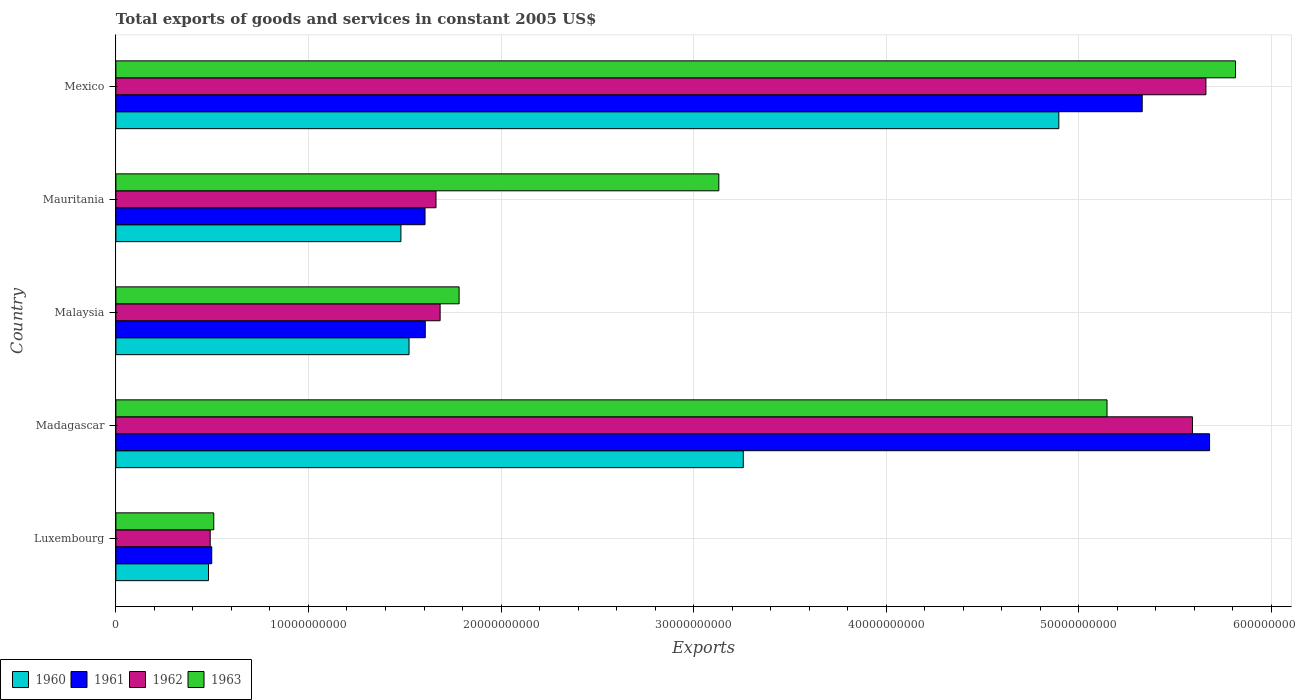What is the label of the 5th group of bars from the top?
Keep it short and to the point. Luxembourg. In how many cases, is the number of bars for a given country not equal to the number of legend labels?
Offer a terse response. 0. What is the total exports of goods and services in 1963 in Malaysia?
Keep it short and to the point. 1.78e+1. Across all countries, what is the maximum total exports of goods and services in 1962?
Your response must be concise. 5.66e+1. Across all countries, what is the minimum total exports of goods and services in 1962?
Offer a terse response. 4.90e+09. In which country was the total exports of goods and services in 1960 minimum?
Keep it short and to the point. Luxembourg. What is the total total exports of goods and services in 1961 in the graph?
Provide a short and direct response. 1.47e+11. What is the difference between the total exports of goods and services in 1962 in Luxembourg and that in Malaysia?
Offer a terse response. -1.19e+1. What is the difference between the total exports of goods and services in 1960 in Luxembourg and the total exports of goods and services in 1961 in Mexico?
Ensure brevity in your answer.  -4.85e+1. What is the average total exports of goods and services in 1962 per country?
Your answer should be very brief. 3.02e+1. What is the difference between the total exports of goods and services in 1963 and total exports of goods and services in 1960 in Malaysia?
Your answer should be compact. 2.60e+09. What is the ratio of the total exports of goods and services in 1963 in Madagascar to that in Mexico?
Ensure brevity in your answer.  0.89. Is the total exports of goods and services in 1962 in Madagascar less than that in Malaysia?
Offer a terse response. No. Is the difference between the total exports of goods and services in 1963 in Luxembourg and Mauritania greater than the difference between the total exports of goods and services in 1960 in Luxembourg and Mauritania?
Offer a very short reply. No. What is the difference between the highest and the second highest total exports of goods and services in 1962?
Your answer should be compact. 6.99e+08. What is the difference between the highest and the lowest total exports of goods and services in 1961?
Give a very brief answer. 5.18e+1. In how many countries, is the total exports of goods and services in 1960 greater than the average total exports of goods and services in 1960 taken over all countries?
Your answer should be compact. 2. Is it the case that in every country, the sum of the total exports of goods and services in 1961 and total exports of goods and services in 1962 is greater than the sum of total exports of goods and services in 1963 and total exports of goods and services in 1960?
Ensure brevity in your answer.  No. What does the 2nd bar from the bottom in Luxembourg represents?
Give a very brief answer. 1961. What is the difference between two consecutive major ticks on the X-axis?
Offer a very short reply. 1.00e+1. Does the graph contain any zero values?
Your answer should be very brief. No. Does the graph contain grids?
Make the answer very short. Yes. Where does the legend appear in the graph?
Your response must be concise. Bottom left. What is the title of the graph?
Offer a terse response. Total exports of goods and services in constant 2005 US$. Does "1999" appear as one of the legend labels in the graph?
Your answer should be compact. No. What is the label or title of the X-axis?
Make the answer very short. Exports. What is the label or title of the Y-axis?
Your answer should be compact. Country. What is the Exports in 1960 in Luxembourg?
Keep it short and to the point. 4.81e+09. What is the Exports of 1961 in Luxembourg?
Your answer should be very brief. 4.98e+09. What is the Exports of 1962 in Luxembourg?
Provide a succinct answer. 4.90e+09. What is the Exports in 1963 in Luxembourg?
Make the answer very short. 5.08e+09. What is the Exports of 1960 in Madagascar?
Provide a short and direct response. 3.26e+1. What is the Exports of 1961 in Madagascar?
Your answer should be very brief. 5.68e+1. What is the Exports of 1962 in Madagascar?
Provide a succinct answer. 5.59e+1. What is the Exports in 1963 in Madagascar?
Offer a very short reply. 5.15e+1. What is the Exports in 1960 in Malaysia?
Provide a short and direct response. 1.52e+1. What is the Exports in 1961 in Malaysia?
Keep it short and to the point. 1.61e+1. What is the Exports in 1962 in Malaysia?
Your response must be concise. 1.68e+1. What is the Exports in 1963 in Malaysia?
Offer a very short reply. 1.78e+1. What is the Exports in 1960 in Mauritania?
Keep it short and to the point. 1.48e+1. What is the Exports of 1961 in Mauritania?
Offer a very short reply. 1.61e+1. What is the Exports of 1962 in Mauritania?
Your response must be concise. 1.66e+1. What is the Exports in 1963 in Mauritania?
Make the answer very short. 3.13e+1. What is the Exports of 1960 in Mexico?
Your response must be concise. 4.90e+1. What is the Exports in 1961 in Mexico?
Provide a short and direct response. 5.33e+1. What is the Exports of 1962 in Mexico?
Offer a very short reply. 5.66e+1. What is the Exports in 1963 in Mexico?
Provide a succinct answer. 5.81e+1. Across all countries, what is the maximum Exports in 1960?
Make the answer very short. 4.90e+1. Across all countries, what is the maximum Exports in 1961?
Provide a short and direct response. 5.68e+1. Across all countries, what is the maximum Exports of 1962?
Keep it short and to the point. 5.66e+1. Across all countries, what is the maximum Exports in 1963?
Your response must be concise. 5.81e+1. Across all countries, what is the minimum Exports in 1960?
Your response must be concise. 4.81e+09. Across all countries, what is the minimum Exports of 1961?
Provide a short and direct response. 4.98e+09. Across all countries, what is the minimum Exports of 1962?
Provide a succinct answer. 4.90e+09. Across all countries, what is the minimum Exports of 1963?
Ensure brevity in your answer.  5.08e+09. What is the total Exports of 1960 in the graph?
Offer a very short reply. 1.16e+11. What is the total Exports in 1961 in the graph?
Make the answer very short. 1.47e+11. What is the total Exports in 1962 in the graph?
Your answer should be compact. 1.51e+11. What is the total Exports of 1963 in the graph?
Keep it short and to the point. 1.64e+11. What is the difference between the Exports of 1960 in Luxembourg and that in Madagascar?
Your answer should be compact. -2.78e+1. What is the difference between the Exports in 1961 in Luxembourg and that in Madagascar?
Provide a short and direct response. -5.18e+1. What is the difference between the Exports in 1962 in Luxembourg and that in Madagascar?
Ensure brevity in your answer.  -5.10e+1. What is the difference between the Exports of 1963 in Luxembourg and that in Madagascar?
Your answer should be very brief. -4.64e+1. What is the difference between the Exports of 1960 in Luxembourg and that in Malaysia?
Make the answer very short. -1.04e+1. What is the difference between the Exports of 1961 in Luxembourg and that in Malaysia?
Make the answer very short. -1.11e+1. What is the difference between the Exports in 1962 in Luxembourg and that in Malaysia?
Your answer should be very brief. -1.19e+1. What is the difference between the Exports in 1963 in Luxembourg and that in Malaysia?
Your answer should be very brief. -1.27e+1. What is the difference between the Exports in 1960 in Luxembourg and that in Mauritania?
Offer a very short reply. -9.99e+09. What is the difference between the Exports of 1961 in Luxembourg and that in Mauritania?
Provide a short and direct response. -1.11e+1. What is the difference between the Exports of 1962 in Luxembourg and that in Mauritania?
Offer a very short reply. -1.17e+1. What is the difference between the Exports of 1963 in Luxembourg and that in Mauritania?
Offer a very short reply. -2.62e+1. What is the difference between the Exports of 1960 in Luxembourg and that in Mexico?
Provide a succinct answer. -4.42e+1. What is the difference between the Exports in 1961 in Luxembourg and that in Mexico?
Offer a terse response. -4.83e+1. What is the difference between the Exports in 1962 in Luxembourg and that in Mexico?
Provide a succinct answer. -5.17e+1. What is the difference between the Exports of 1963 in Luxembourg and that in Mexico?
Ensure brevity in your answer.  -5.31e+1. What is the difference between the Exports in 1960 in Madagascar and that in Malaysia?
Provide a short and direct response. 1.74e+1. What is the difference between the Exports in 1961 in Madagascar and that in Malaysia?
Your response must be concise. 4.07e+1. What is the difference between the Exports in 1962 in Madagascar and that in Malaysia?
Ensure brevity in your answer.  3.91e+1. What is the difference between the Exports of 1963 in Madagascar and that in Malaysia?
Your response must be concise. 3.36e+1. What is the difference between the Exports in 1960 in Madagascar and that in Mauritania?
Offer a terse response. 1.78e+1. What is the difference between the Exports in 1961 in Madagascar and that in Mauritania?
Provide a succinct answer. 4.07e+1. What is the difference between the Exports of 1962 in Madagascar and that in Mauritania?
Ensure brevity in your answer.  3.93e+1. What is the difference between the Exports in 1963 in Madagascar and that in Mauritania?
Provide a short and direct response. 2.02e+1. What is the difference between the Exports of 1960 in Madagascar and that in Mexico?
Offer a terse response. -1.64e+1. What is the difference between the Exports in 1961 in Madagascar and that in Mexico?
Your answer should be very brief. 3.50e+09. What is the difference between the Exports in 1962 in Madagascar and that in Mexico?
Give a very brief answer. -6.99e+08. What is the difference between the Exports in 1963 in Madagascar and that in Mexico?
Your response must be concise. -6.67e+09. What is the difference between the Exports of 1960 in Malaysia and that in Mauritania?
Your answer should be very brief. 4.22e+08. What is the difference between the Exports of 1961 in Malaysia and that in Mauritania?
Make the answer very short. 1.20e+07. What is the difference between the Exports of 1962 in Malaysia and that in Mauritania?
Make the answer very short. 2.15e+08. What is the difference between the Exports in 1963 in Malaysia and that in Mauritania?
Offer a terse response. -1.35e+1. What is the difference between the Exports of 1960 in Malaysia and that in Mexico?
Offer a terse response. -3.37e+1. What is the difference between the Exports of 1961 in Malaysia and that in Mexico?
Keep it short and to the point. -3.72e+1. What is the difference between the Exports of 1962 in Malaysia and that in Mexico?
Provide a succinct answer. -3.98e+1. What is the difference between the Exports of 1963 in Malaysia and that in Mexico?
Make the answer very short. -4.03e+1. What is the difference between the Exports of 1960 in Mauritania and that in Mexico?
Ensure brevity in your answer.  -3.42e+1. What is the difference between the Exports of 1961 in Mauritania and that in Mexico?
Offer a terse response. -3.72e+1. What is the difference between the Exports of 1962 in Mauritania and that in Mexico?
Provide a short and direct response. -4.00e+1. What is the difference between the Exports in 1963 in Mauritania and that in Mexico?
Your response must be concise. -2.68e+1. What is the difference between the Exports of 1960 in Luxembourg and the Exports of 1961 in Madagascar?
Give a very brief answer. -5.20e+1. What is the difference between the Exports of 1960 in Luxembourg and the Exports of 1962 in Madagascar?
Offer a very short reply. -5.11e+1. What is the difference between the Exports in 1960 in Luxembourg and the Exports in 1963 in Madagascar?
Your answer should be compact. -4.67e+1. What is the difference between the Exports of 1961 in Luxembourg and the Exports of 1962 in Madagascar?
Provide a short and direct response. -5.09e+1. What is the difference between the Exports in 1961 in Luxembourg and the Exports in 1963 in Madagascar?
Offer a very short reply. -4.65e+1. What is the difference between the Exports of 1962 in Luxembourg and the Exports of 1963 in Madagascar?
Make the answer very short. -4.66e+1. What is the difference between the Exports in 1960 in Luxembourg and the Exports in 1961 in Malaysia?
Provide a succinct answer. -1.13e+1. What is the difference between the Exports of 1960 in Luxembourg and the Exports of 1962 in Malaysia?
Ensure brevity in your answer.  -1.20e+1. What is the difference between the Exports in 1960 in Luxembourg and the Exports in 1963 in Malaysia?
Your response must be concise. -1.30e+1. What is the difference between the Exports in 1961 in Luxembourg and the Exports in 1962 in Malaysia?
Your answer should be compact. -1.19e+1. What is the difference between the Exports of 1961 in Luxembourg and the Exports of 1963 in Malaysia?
Provide a succinct answer. -1.28e+1. What is the difference between the Exports in 1962 in Luxembourg and the Exports in 1963 in Malaysia?
Offer a very short reply. -1.29e+1. What is the difference between the Exports in 1960 in Luxembourg and the Exports in 1961 in Mauritania?
Offer a very short reply. -1.12e+1. What is the difference between the Exports in 1960 in Luxembourg and the Exports in 1962 in Mauritania?
Keep it short and to the point. -1.18e+1. What is the difference between the Exports in 1960 in Luxembourg and the Exports in 1963 in Mauritania?
Offer a terse response. -2.65e+1. What is the difference between the Exports in 1961 in Luxembourg and the Exports in 1962 in Mauritania?
Provide a short and direct response. -1.16e+1. What is the difference between the Exports of 1961 in Luxembourg and the Exports of 1963 in Mauritania?
Make the answer very short. -2.63e+1. What is the difference between the Exports of 1962 in Luxembourg and the Exports of 1963 in Mauritania?
Keep it short and to the point. -2.64e+1. What is the difference between the Exports of 1960 in Luxembourg and the Exports of 1961 in Mexico?
Provide a short and direct response. -4.85e+1. What is the difference between the Exports in 1960 in Luxembourg and the Exports in 1962 in Mexico?
Provide a succinct answer. -5.18e+1. What is the difference between the Exports in 1960 in Luxembourg and the Exports in 1963 in Mexico?
Provide a short and direct response. -5.33e+1. What is the difference between the Exports in 1961 in Luxembourg and the Exports in 1962 in Mexico?
Provide a short and direct response. -5.16e+1. What is the difference between the Exports in 1961 in Luxembourg and the Exports in 1963 in Mexico?
Ensure brevity in your answer.  -5.32e+1. What is the difference between the Exports of 1962 in Luxembourg and the Exports of 1963 in Mexico?
Provide a succinct answer. -5.32e+1. What is the difference between the Exports of 1960 in Madagascar and the Exports of 1961 in Malaysia?
Offer a terse response. 1.65e+1. What is the difference between the Exports of 1960 in Madagascar and the Exports of 1962 in Malaysia?
Your answer should be very brief. 1.57e+1. What is the difference between the Exports in 1960 in Madagascar and the Exports in 1963 in Malaysia?
Your answer should be very brief. 1.48e+1. What is the difference between the Exports in 1961 in Madagascar and the Exports in 1962 in Malaysia?
Offer a terse response. 4.00e+1. What is the difference between the Exports of 1961 in Madagascar and the Exports of 1963 in Malaysia?
Keep it short and to the point. 3.90e+1. What is the difference between the Exports in 1962 in Madagascar and the Exports in 1963 in Malaysia?
Ensure brevity in your answer.  3.81e+1. What is the difference between the Exports of 1960 in Madagascar and the Exports of 1961 in Mauritania?
Offer a terse response. 1.65e+1. What is the difference between the Exports in 1960 in Madagascar and the Exports in 1962 in Mauritania?
Your answer should be very brief. 1.60e+1. What is the difference between the Exports in 1960 in Madagascar and the Exports in 1963 in Mauritania?
Provide a short and direct response. 1.27e+09. What is the difference between the Exports in 1961 in Madagascar and the Exports in 1962 in Mauritania?
Your answer should be very brief. 4.02e+1. What is the difference between the Exports of 1961 in Madagascar and the Exports of 1963 in Mauritania?
Keep it short and to the point. 2.55e+1. What is the difference between the Exports of 1962 in Madagascar and the Exports of 1963 in Mauritania?
Ensure brevity in your answer.  2.46e+1. What is the difference between the Exports of 1960 in Madagascar and the Exports of 1961 in Mexico?
Offer a very short reply. -2.07e+1. What is the difference between the Exports in 1960 in Madagascar and the Exports in 1962 in Mexico?
Ensure brevity in your answer.  -2.40e+1. What is the difference between the Exports in 1960 in Madagascar and the Exports in 1963 in Mexico?
Give a very brief answer. -2.56e+1. What is the difference between the Exports in 1961 in Madagascar and the Exports in 1962 in Mexico?
Your response must be concise. 1.89e+08. What is the difference between the Exports in 1961 in Madagascar and the Exports in 1963 in Mexico?
Provide a short and direct response. -1.35e+09. What is the difference between the Exports in 1962 in Madagascar and the Exports in 1963 in Mexico?
Offer a very short reply. -2.24e+09. What is the difference between the Exports of 1960 in Malaysia and the Exports of 1961 in Mauritania?
Your response must be concise. -8.31e+08. What is the difference between the Exports of 1960 in Malaysia and the Exports of 1962 in Mauritania?
Make the answer very short. -1.40e+09. What is the difference between the Exports in 1960 in Malaysia and the Exports in 1963 in Mauritania?
Your answer should be very brief. -1.61e+1. What is the difference between the Exports of 1961 in Malaysia and the Exports of 1962 in Mauritania?
Provide a succinct answer. -5.57e+08. What is the difference between the Exports in 1961 in Malaysia and the Exports in 1963 in Mauritania?
Offer a very short reply. -1.52e+1. What is the difference between the Exports of 1962 in Malaysia and the Exports of 1963 in Mauritania?
Provide a succinct answer. -1.45e+1. What is the difference between the Exports of 1960 in Malaysia and the Exports of 1961 in Mexico?
Give a very brief answer. -3.81e+1. What is the difference between the Exports in 1960 in Malaysia and the Exports in 1962 in Mexico?
Make the answer very short. -4.14e+1. What is the difference between the Exports in 1960 in Malaysia and the Exports in 1963 in Mexico?
Provide a succinct answer. -4.29e+1. What is the difference between the Exports of 1961 in Malaysia and the Exports of 1962 in Mexico?
Offer a terse response. -4.05e+1. What is the difference between the Exports of 1961 in Malaysia and the Exports of 1963 in Mexico?
Make the answer very short. -4.21e+1. What is the difference between the Exports in 1962 in Malaysia and the Exports in 1963 in Mexico?
Offer a very short reply. -4.13e+1. What is the difference between the Exports in 1960 in Mauritania and the Exports in 1961 in Mexico?
Give a very brief answer. -3.85e+1. What is the difference between the Exports of 1960 in Mauritania and the Exports of 1962 in Mexico?
Ensure brevity in your answer.  -4.18e+1. What is the difference between the Exports in 1960 in Mauritania and the Exports in 1963 in Mexico?
Offer a terse response. -4.33e+1. What is the difference between the Exports in 1961 in Mauritania and the Exports in 1962 in Mexico?
Your response must be concise. -4.05e+1. What is the difference between the Exports in 1961 in Mauritania and the Exports in 1963 in Mexico?
Your answer should be compact. -4.21e+1. What is the difference between the Exports of 1962 in Mauritania and the Exports of 1963 in Mexico?
Make the answer very short. -4.15e+1. What is the average Exports of 1960 per country?
Give a very brief answer. 2.33e+1. What is the average Exports in 1961 per country?
Make the answer very short. 2.94e+1. What is the average Exports of 1962 per country?
Keep it short and to the point. 3.02e+1. What is the average Exports in 1963 per country?
Your answer should be very brief. 3.28e+1. What is the difference between the Exports in 1960 and Exports in 1961 in Luxembourg?
Provide a succinct answer. -1.68e+08. What is the difference between the Exports of 1960 and Exports of 1962 in Luxembourg?
Keep it short and to the point. -8.82e+07. What is the difference between the Exports of 1960 and Exports of 1963 in Luxembourg?
Provide a short and direct response. -2.73e+08. What is the difference between the Exports of 1961 and Exports of 1962 in Luxembourg?
Your answer should be compact. 7.94e+07. What is the difference between the Exports of 1961 and Exports of 1963 in Luxembourg?
Your response must be concise. -1.05e+08. What is the difference between the Exports in 1962 and Exports in 1963 in Luxembourg?
Your answer should be very brief. -1.85e+08. What is the difference between the Exports of 1960 and Exports of 1961 in Madagascar?
Make the answer very short. -2.42e+1. What is the difference between the Exports of 1960 and Exports of 1962 in Madagascar?
Offer a very short reply. -2.33e+1. What is the difference between the Exports in 1960 and Exports in 1963 in Madagascar?
Your answer should be very brief. -1.89e+1. What is the difference between the Exports in 1961 and Exports in 1962 in Madagascar?
Your answer should be compact. 8.87e+08. What is the difference between the Exports in 1961 and Exports in 1963 in Madagascar?
Your response must be concise. 5.32e+09. What is the difference between the Exports of 1962 and Exports of 1963 in Madagascar?
Your response must be concise. 4.44e+09. What is the difference between the Exports in 1960 and Exports in 1961 in Malaysia?
Provide a succinct answer. -8.42e+08. What is the difference between the Exports of 1960 and Exports of 1962 in Malaysia?
Keep it short and to the point. -1.61e+09. What is the difference between the Exports of 1960 and Exports of 1963 in Malaysia?
Ensure brevity in your answer.  -2.60e+09. What is the difference between the Exports of 1961 and Exports of 1962 in Malaysia?
Make the answer very short. -7.72e+08. What is the difference between the Exports of 1961 and Exports of 1963 in Malaysia?
Your answer should be compact. -1.76e+09. What is the difference between the Exports of 1962 and Exports of 1963 in Malaysia?
Give a very brief answer. -9.85e+08. What is the difference between the Exports of 1960 and Exports of 1961 in Mauritania?
Keep it short and to the point. -1.25e+09. What is the difference between the Exports in 1960 and Exports in 1962 in Mauritania?
Your answer should be compact. -1.82e+09. What is the difference between the Exports of 1960 and Exports of 1963 in Mauritania?
Provide a succinct answer. -1.65e+1. What is the difference between the Exports in 1961 and Exports in 1962 in Mauritania?
Your answer should be very brief. -5.69e+08. What is the difference between the Exports in 1961 and Exports in 1963 in Mauritania?
Provide a short and direct response. -1.53e+1. What is the difference between the Exports in 1962 and Exports in 1963 in Mauritania?
Provide a short and direct response. -1.47e+1. What is the difference between the Exports of 1960 and Exports of 1961 in Mexico?
Provide a short and direct response. -4.33e+09. What is the difference between the Exports of 1960 and Exports of 1962 in Mexico?
Your response must be concise. -7.64e+09. What is the difference between the Exports in 1960 and Exports in 1963 in Mexico?
Your response must be concise. -9.17e+09. What is the difference between the Exports in 1961 and Exports in 1962 in Mexico?
Give a very brief answer. -3.31e+09. What is the difference between the Exports of 1961 and Exports of 1963 in Mexico?
Ensure brevity in your answer.  -4.84e+09. What is the difference between the Exports in 1962 and Exports in 1963 in Mexico?
Your answer should be compact. -1.54e+09. What is the ratio of the Exports of 1960 in Luxembourg to that in Madagascar?
Your answer should be very brief. 0.15. What is the ratio of the Exports in 1961 in Luxembourg to that in Madagascar?
Offer a terse response. 0.09. What is the ratio of the Exports of 1962 in Luxembourg to that in Madagascar?
Your answer should be compact. 0.09. What is the ratio of the Exports in 1963 in Luxembourg to that in Madagascar?
Your answer should be compact. 0.1. What is the ratio of the Exports in 1960 in Luxembourg to that in Malaysia?
Your answer should be compact. 0.32. What is the ratio of the Exports in 1961 in Luxembourg to that in Malaysia?
Your answer should be compact. 0.31. What is the ratio of the Exports of 1962 in Luxembourg to that in Malaysia?
Your answer should be very brief. 0.29. What is the ratio of the Exports in 1963 in Luxembourg to that in Malaysia?
Your response must be concise. 0.29. What is the ratio of the Exports in 1960 in Luxembourg to that in Mauritania?
Make the answer very short. 0.32. What is the ratio of the Exports in 1961 in Luxembourg to that in Mauritania?
Provide a succinct answer. 0.31. What is the ratio of the Exports in 1962 in Luxembourg to that in Mauritania?
Provide a short and direct response. 0.29. What is the ratio of the Exports of 1963 in Luxembourg to that in Mauritania?
Make the answer very short. 0.16. What is the ratio of the Exports of 1960 in Luxembourg to that in Mexico?
Provide a short and direct response. 0.1. What is the ratio of the Exports in 1961 in Luxembourg to that in Mexico?
Your answer should be very brief. 0.09. What is the ratio of the Exports in 1962 in Luxembourg to that in Mexico?
Make the answer very short. 0.09. What is the ratio of the Exports of 1963 in Luxembourg to that in Mexico?
Keep it short and to the point. 0.09. What is the ratio of the Exports in 1960 in Madagascar to that in Malaysia?
Keep it short and to the point. 2.14. What is the ratio of the Exports of 1961 in Madagascar to that in Malaysia?
Your answer should be very brief. 3.54. What is the ratio of the Exports of 1962 in Madagascar to that in Malaysia?
Ensure brevity in your answer.  3.32. What is the ratio of the Exports in 1963 in Madagascar to that in Malaysia?
Provide a succinct answer. 2.89. What is the ratio of the Exports in 1960 in Madagascar to that in Mauritania?
Keep it short and to the point. 2.2. What is the ratio of the Exports in 1961 in Madagascar to that in Mauritania?
Offer a terse response. 3.54. What is the ratio of the Exports of 1962 in Madagascar to that in Mauritania?
Provide a short and direct response. 3.36. What is the ratio of the Exports in 1963 in Madagascar to that in Mauritania?
Make the answer very short. 1.64. What is the ratio of the Exports in 1960 in Madagascar to that in Mexico?
Offer a terse response. 0.67. What is the ratio of the Exports of 1961 in Madagascar to that in Mexico?
Offer a very short reply. 1.07. What is the ratio of the Exports of 1962 in Madagascar to that in Mexico?
Ensure brevity in your answer.  0.99. What is the ratio of the Exports of 1963 in Madagascar to that in Mexico?
Provide a short and direct response. 0.89. What is the ratio of the Exports of 1960 in Malaysia to that in Mauritania?
Your response must be concise. 1.03. What is the ratio of the Exports of 1962 in Malaysia to that in Mauritania?
Your answer should be very brief. 1.01. What is the ratio of the Exports in 1963 in Malaysia to that in Mauritania?
Keep it short and to the point. 0.57. What is the ratio of the Exports in 1960 in Malaysia to that in Mexico?
Your answer should be very brief. 0.31. What is the ratio of the Exports of 1961 in Malaysia to that in Mexico?
Make the answer very short. 0.3. What is the ratio of the Exports in 1962 in Malaysia to that in Mexico?
Your answer should be compact. 0.3. What is the ratio of the Exports of 1963 in Malaysia to that in Mexico?
Provide a short and direct response. 0.31. What is the ratio of the Exports in 1960 in Mauritania to that in Mexico?
Provide a succinct answer. 0.3. What is the ratio of the Exports of 1961 in Mauritania to that in Mexico?
Ensure brevity in your answer.  0.3. What is the ratio of the Exports in 1962 in Mauritania to that in Mexico?
Make the answer very short. 0.29. What is the ratio of the Exports of 1963 in Mauritania to that in Mexico?
Make the answer very short. 0.54. What is the difference between the highest and the second highest Exports in 1960?
Provide a succinct answer. 1.64e+1. What is the difference between the highest and the second highest Exports of 1961?
Ensure brevity in your answer.  3.50e+09. What is the difference between the highest and the second highest Exports in 1962?
Keep it short and to the point. 6.99e+08. What is the difference between the highest and the second highest Exports of 1963?
Keep it short and to the point. 6.67e+09. What is the difference between the highest and the lowest Exports in 1960?
Provide a short and direct response. 4.42e+1. What is the difference between the highest and the lowest Exports of 1961?
Provide a succinct answer. 5.18e+1. What is the difference between the highest and the lowest Exports in 1962?
Offer a terse response. 5.17e+1. What is the difference between the highest and the lowest Exports of 1963?
Your answer should be very brief. 5.31e+1. 